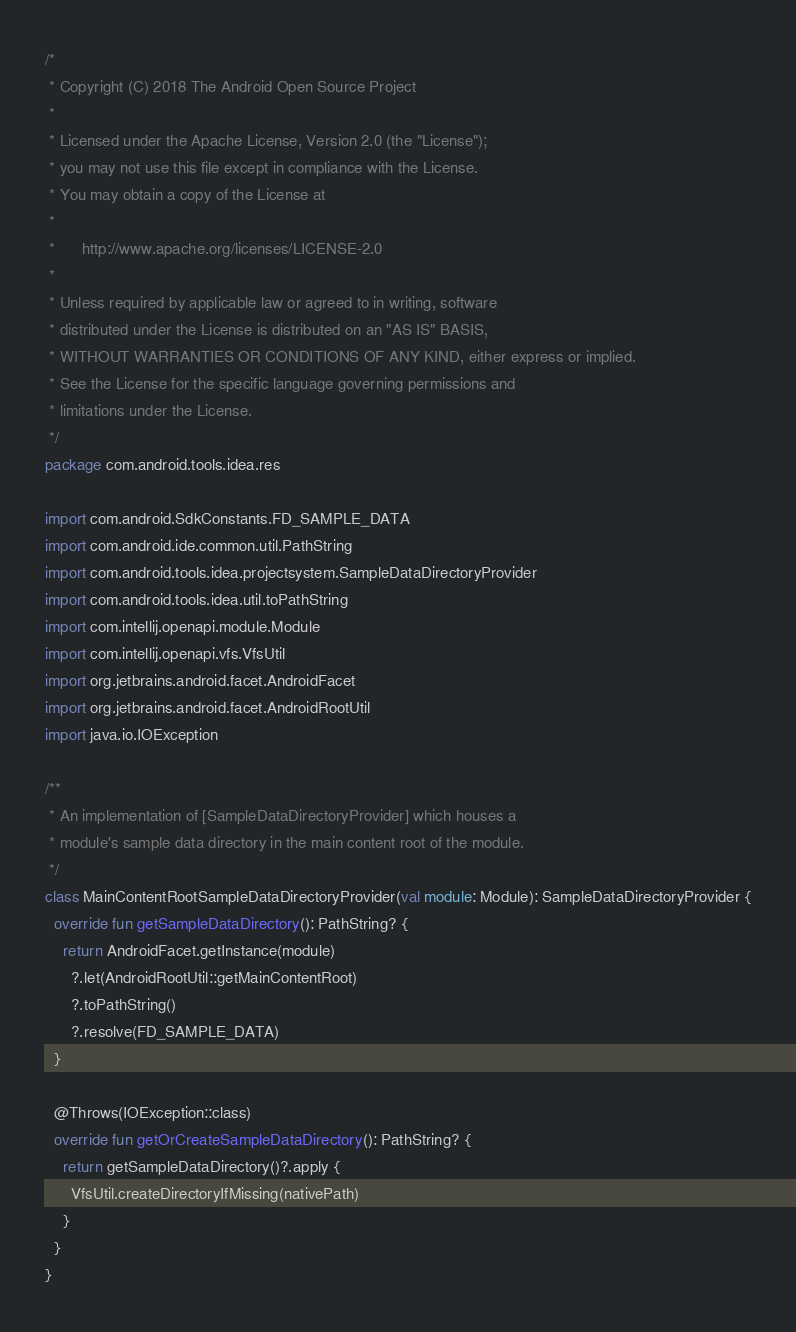<code> <loc_0><loc_0><loc_500><loc_500><_Kotlin_>/*
 * Copyright (C) 2018 The Android Open Source Project
 *
 * Licensed under the Apache License, Version 2.0 (the "License");
 * you may not use this file except in compliance with the License.
 * You may obtain a copy of the License at
 *
 *      http://www.apache.org/licenses/LICENSE-2.0
 *
 * Unless required by applicable law or agreed to in writing, software
 * distributed under the License is distributed on an "AS IS" BASIS,
 * WITHOUT WARRANTIES OR CONDITIONS OF ANY KIND, either express or implied.
 * See the License for the specific language governing permissions and
 * limitations under the License.
 */
package com.android.tools.idea.res

import com.android.SdkConstants.FD_SAMPLE_DATA
import com.android.ide.common.util.PathString
import com.android.tools.idea.projectsystem.SampleDataDirectoryProvider
import com.android.tools.idea.util.toPathString
import com.intellij.openapi.module.Module
import com.intellij.openapi.vfs.VfsUtil
import org.jetbrains.android.facet.AndroidFacet
import org.jetbrains.android.facet.AndroidRootUtil
import java.io.IOException

/**
 * An implementation of [SampleDataDirectoryProvider] which houses a
 * module's sample data directory in the main content root of the module.
 */
class MainContentRootSampleDataDirectoryProvider(val module: Module): SampleDataDirectoryProvider {
  override fun getSampleDataDirectory(): PathString? {
    return AndroidFacet.getInstance(module)
      ?.let(AndroidRootUtil::getMainContentRoot)
      ?.toPathString()
      ?.resolve(FD_SAMPLE_DATA)
  }

  @Throws(IOException::class)
  override fun getOrCreateSampleDataDirectory(): PathString? {
    return getSampleDataDirectory()?.apply {
      VfsUtil.createDirectoryIfMissing(nativePath)
    }
  }
}</code> 